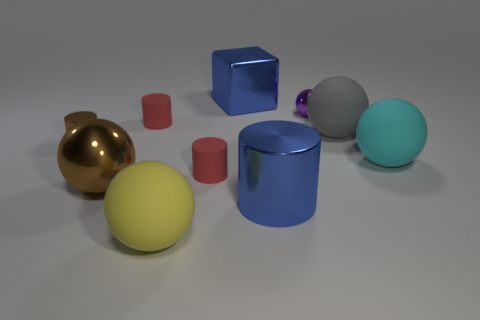Is there a blue object that has the same shape as the large brown thing?
Provide a succinct answer. No. What is the shape of the cyan object that is the same size as the yellow rubber thing?
Keep it short and to the point. Sphere. Is the number of big brown metallic spheres that are behind the large block the same as the number of things in front of the large yellow rubber thing?
Provide a short and direct response. Yes. How big is the cylinder right of the large blue object on the left side of the big blue cylinder?
Make the answer very short. Large. Is there a red matte thing of the same size as the brown metallic sphere?
Your answer should be very brief. No. What is the color of the other tiny thing that is made of the same material as the small brown thing?
Offer a very short reply. Purple. Are there fewer small gray metallic objects than large blue metal cylinders?
Offer a very short reply. Yes. What is the large sphere that is both on the right side of the blue shiny cube and in front of the big gray rubber object made of?
Provide a short and direct response. Rubber. There is a red rubber object that is in front of the brown metal cylinder; are there any large blue metal objects that are in front of it?
Provide a short and direct response. Yes. How many large spheres are the same color as the cube?
Make the answer very short. 0. 